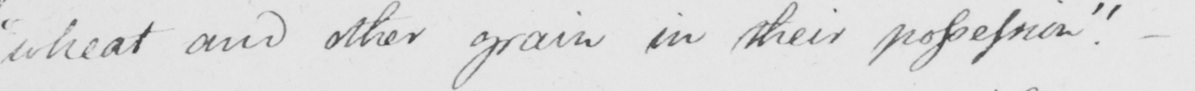What text is written in this handwritten line? "wheat and other grain in their possession." 